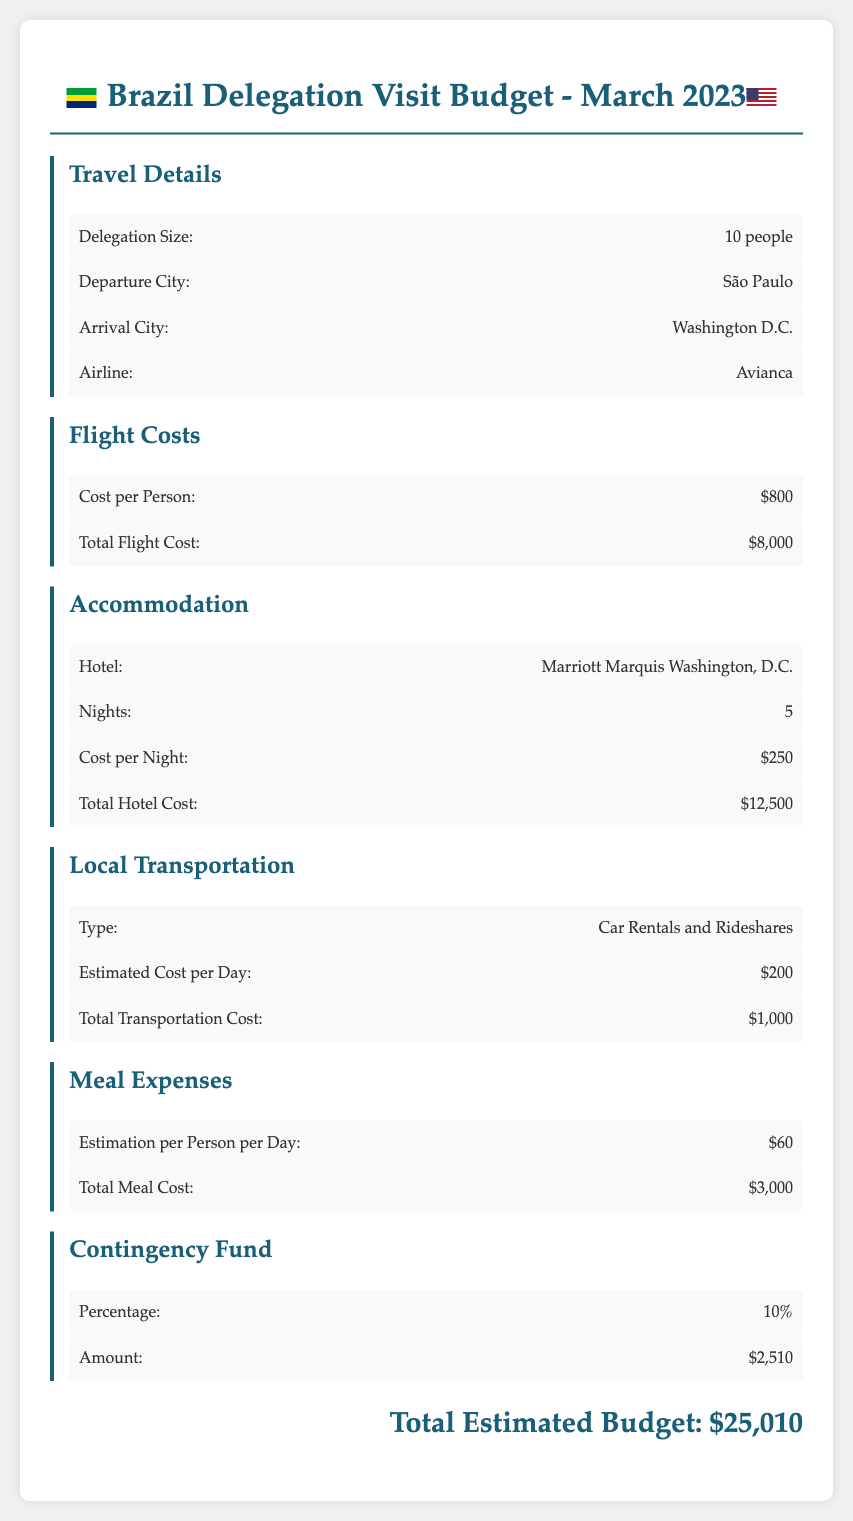What is the delegation size? The delegation size is mentioned under the Travel Details section of the document as 10 people.
Answer: 10 people What is the total hotel cost? The total hotel cost is stated under the Accommodation section, totaling $12,500.
Answer: $12,500 How many nights will the delegation stay? The number of nights is provided in the Accommodation section as 5 nights.
Answer: 5 What is the estimated cost per person for meals? The estimated cost per person for meals is found in the Meal Expenses section as $60.
Answer: $60 What airline will the delegation use? The airline is specified in the Travel Details section as Avianca.
Answer: Avianca What is the total transportation cost? The total transportation cost is indicated under the Local Transportation section, which totals $1,000.
Answer: $1,000 How much is the contingency fund amount? The amount for the contingency fund is detailed in the Contingency Fund section as $2,510.
Answer: $2,510 What is the total estimated budget for the visit? The total estimated budget is stated at the end of the document as $25,010.
Answer: $25,010 What type of local transportation is mentioned? The type of local transportation is specified in the Local Transportation section as Car Rentals and Rideshares.
Answer: Car Rentals and Rideshares 